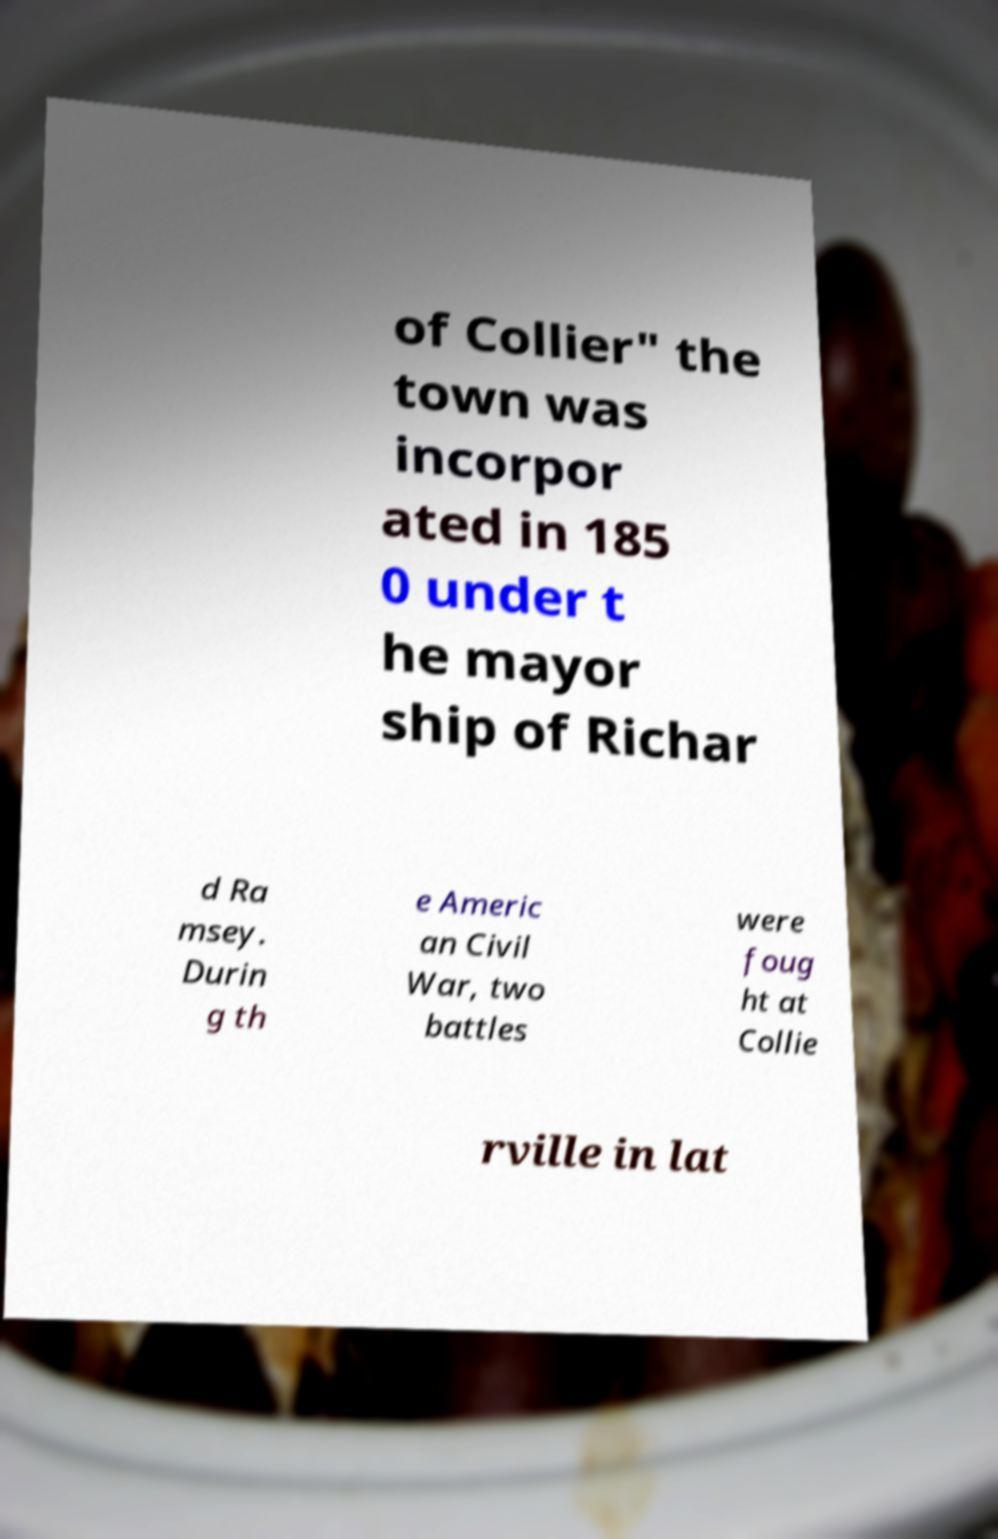Please identify and transcribe the text found in this image. of Collier" the town was incorpor ated in 185 0 under t he mayor ship of Richar d Ra msey. Durin g th e Americ an Civil War, two battles were foug ht at Collie rville in lat 